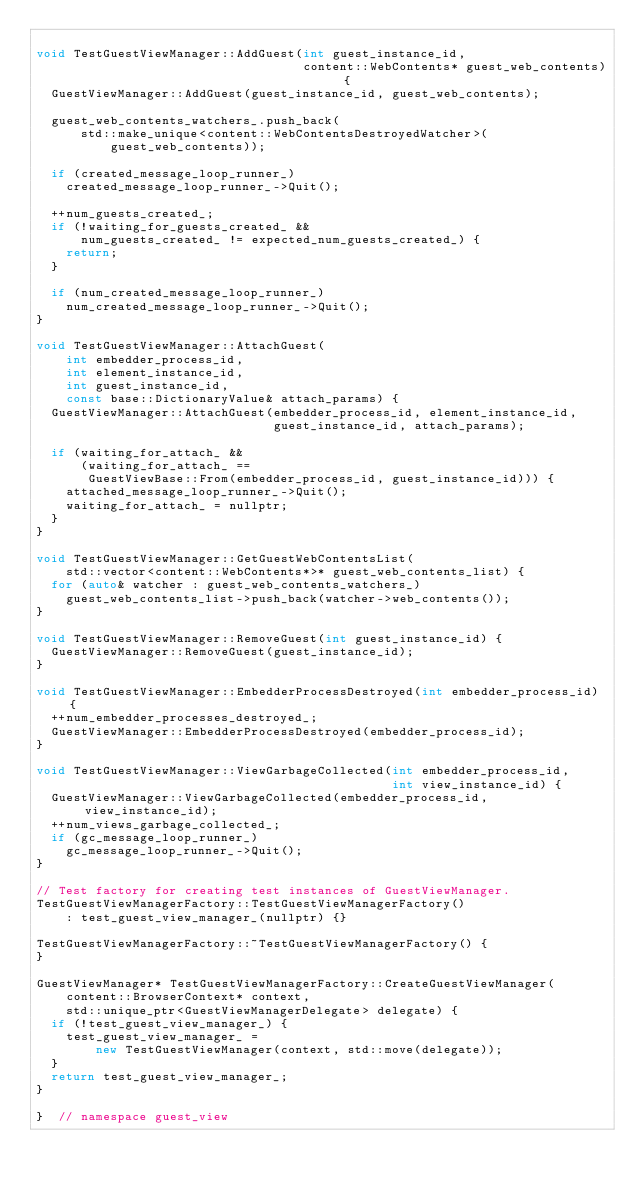Convert code to text. <code><loc_0><loc_0><loc_500><loc_500><_C++_>
void TestGuestViewManager::AddGuest(int guest_instance_id,
                                    content::WebContents* guest_web_contents) {
  GuestViewManager::AddGuest(guest_instance_id, guest_web_contents);

  guest_web_contents_watchers_.push_back(
      std::make_unique<content::WebContentsDestroyedWatcher>(
          guest_web_contents));

  if (created_message_loop_runner_)
    created_message_loop_runner_->Quit();

  ++num_guests_created_;
  if (!waiting_for_guests_created_ &&
      num_guests_created_ != expected_num_guests_created_) {
    return;
  }

  if (num_created_message_loop_runner_)
    num_created_message_loop_runner_->Quit();
}

void TestGuestViewManager::AttachGuest(
    int embedder_process_id,
    int element_instance_id,
    int guest_instance_id,
    const base::DictionaryValue& attach_params) {
  GuestViewManager::AttachGuest(embedder_process_id, element_instance_id,
                                guest_instance_id, attach_params);

  if (waiting_for_attach_ &&
      (waiting_for_attach_ ==
       GuestViewBase::From(embedder_process_id, guest_instance_id))) {
    attached_message_loop_runner_->Quit();
    waiting_for_attach_ = nullptr;
  }
}

void TestGuestViewManager::GetGuestWebContentsList(
    std::vector<content::WebContents*>* guest_web_contents_list) {
  for (auto& watcher : guest_web_contents_watchers_)
    guest_web_contents_list->push_back(watcher->web_contents());
}

void TestGuestViewManager::RemoveGuest(int guest_instance_id) {
  GuestViewManager::RemoveGuest(guest_instance_id);
}

void TestGuestViewManager::EmbedderProcessDestroyed(int embedder_process_id) {
  ++num_embedder_processes_destroyed_;
  GuestViewManager::EmbedderProcessDestroyed(embedder_process_id);
}

void TestGuestViewManager::ViewGarbageCollected(int embedder_process_id,
                                                int view_instance_id) {
  GuestViewManager::ViewGarbageCollected(embedder_process_id, view_instance_id);
  ++num_views_garbage_collected_;
  if (gc_message_loop_runner_)
    gc_message_loop_runner_->Quit();
}

// Test factory for creating test instances of GuestViewManager.
TestGuestViewManagerFactory::TestGuestViewManagerFactory()
    : test_guest_view_manager_(nullptr) {}

TestGuestViewManagerFactory::~TestGuestViewManagerFactory() {
}

GuestViewManager* TestGuestViewManagerFactory::CreateGuestViewManager(
    content::BrowserContext* context,
    std::unique_ptr<GuestViewManagerDelegate> delegate) {
  if (!test_guest_view_manager_) {
    test_guest_view_manager_ =
        new TestGuestViewManager(context, std::move(delegate));
  }
  return test_guest_view_manager_;
}

}  // namespace guest_view
</code> 